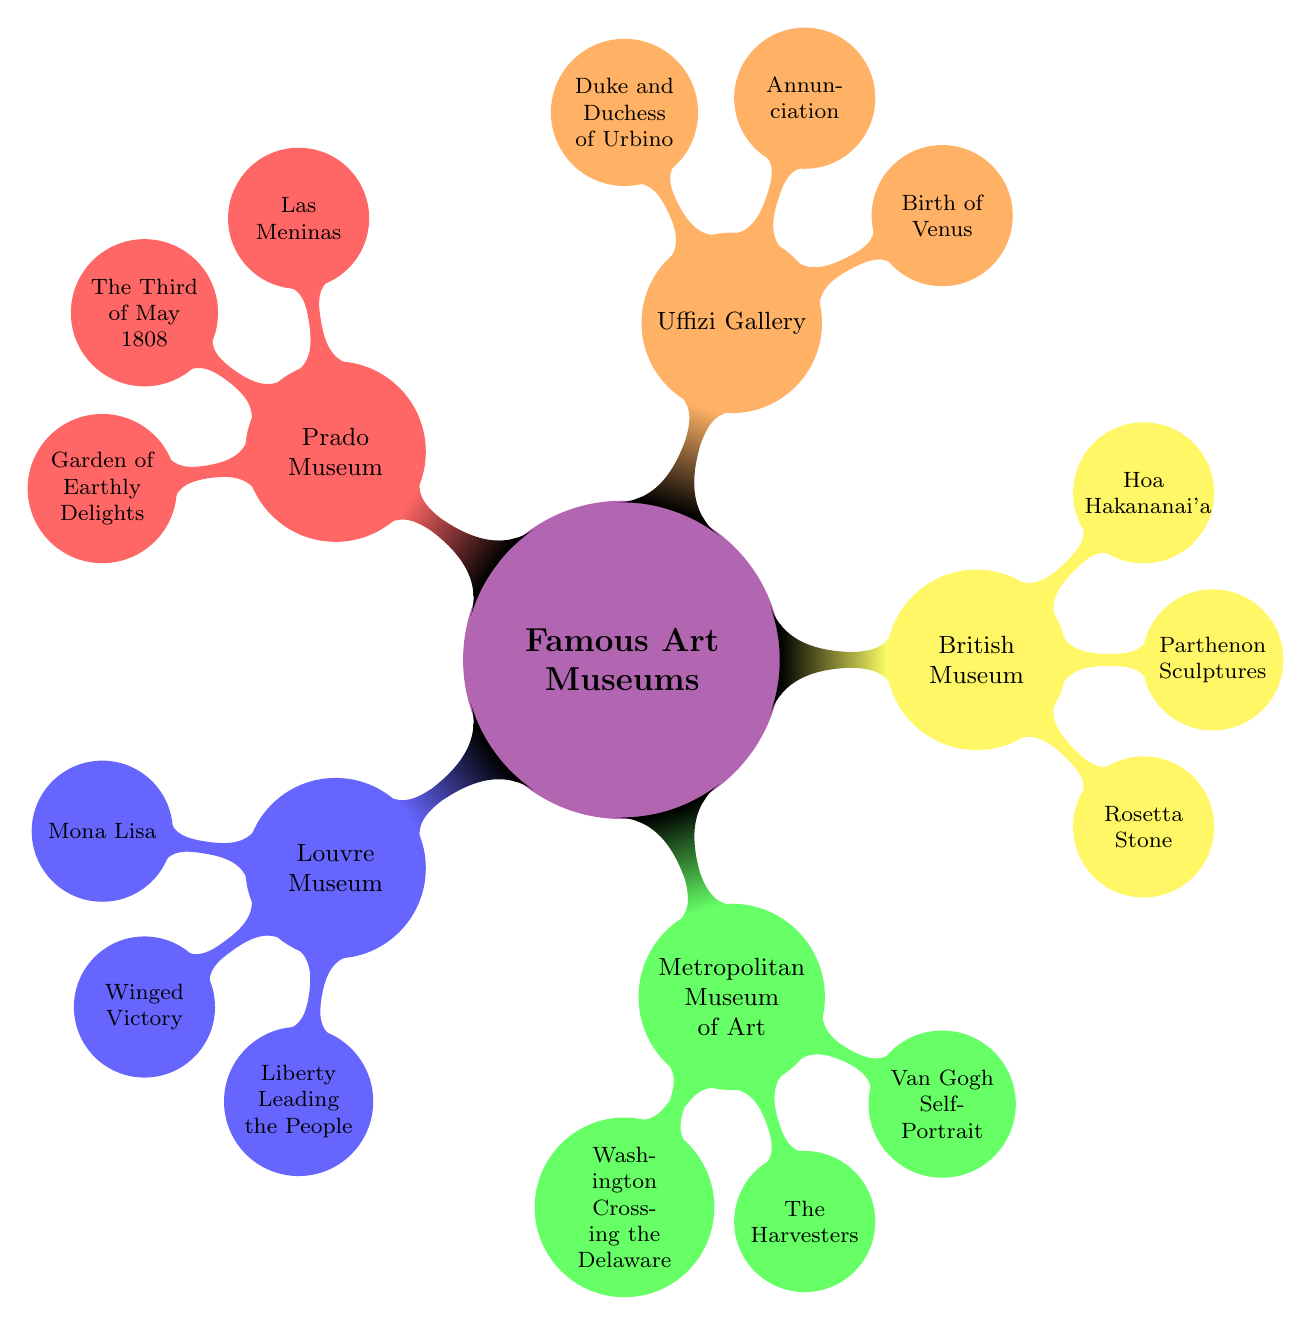What is the location of the Louvre Museum? The diagram indicates that the Louvre Museum is situated in Paris, France.
Answer: Paris, France How many iconic works are listed for the British Museum? In the diagram, the British Museum has three iconic works mentioned: The Rosetta Stone, The Parthenon Sculptures, and Hoa Hakananai'a.
Answer: 3 Which museum features "The Birth of Venus" as an iconic work? According to the diagram, "The Birth of Venus" is an iconic work located in the Uffizi Gallery.
Answer: Uffizi Gallery What is the iconic work associated with the Metropolitan Museum of Art that features a historical event? The diagram specifies that "Washington Crossing the Delaware" is the iconic work connected to a historical event in the Metropolitan Museum of Art.
Answer: Washington Crossing the Delaware Which two museums have iconic works created by Leonardo da Vinci? The diagram shows that both the Louvre Museum and the Uffizi Gallery feature iconic works by Leonardo da Vinci, specifically the "Mona Lisa" and "Annunciation."
Answer: Louvre Museum and Uffizi Gallery How many total museums are represented in this mind map? By examining the diagram, we see five museums listed: Louvre Museum, Metropolitan Museum of Art, British Museum, Uffizi Gallery, and Prado Museum.
Answer: 5 Name an iconic work from the Prado Museum that depicts a social commentary. The diagram presents "The Third of May 1808" as a work from the Prado Museum that illustrates a social commentary.
Answer: The Third of May 1808 